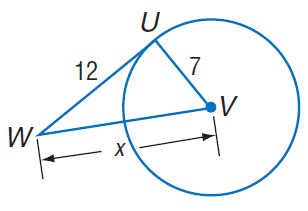Answer the mathemtical geometry problem and directly provide the correct option letter.
Question: Find x. Assume that segments that appear to be tangent are tangent.
Choices: A: 7 B: 12 C: \sqrt { 193 } D: 14 C 